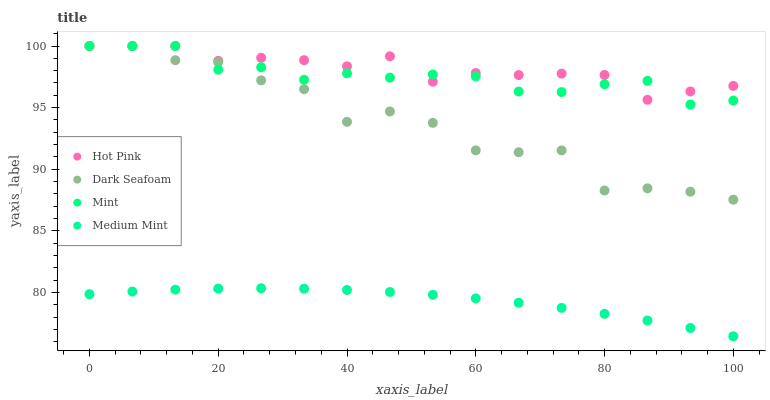Does Medium Mint have the minimum area under the curve?
Answer yes or no. Yes. Does Hot Pink have the maximum area under the curve?
Answer yes or no. Yes. Does Dark Seafoam have the minimum area under the curve?
Answer yes or no. No. Does Dark Seafoam have the maximum area under the curve?
Answer yes or no. No. Is Medium Mint the smoothest?
Answer yes or no. Yes. Is Dark Seafoam the roughest?
Answer yes or no. Yes. Is Hot Pink the smoothest?
Answer yes or no. No. Is Hot Pink the roughest?
Answer yes or no. No. Does Medium Mint have the lowest value?
Answer yes or no. Yes. Does Dark Seafoam have the lowest value?
Answer yes or no. No. Does Mint have the highest value?
Answer yes or no. Yes. Is Medium Mint less than Mint?
Answer yes or no. Yes. Is Dark Seafoam greater than Medium Mint?
Answer yes or no. Yes. Does Hot Pink intersect Mint?
Answer yes or no. Yes. Is Hot Pink less than Mint?
Answer yes or no. No. Is Hot Pink greater than Mint?
Answer yes or no. No. Does Medium Mint intersect Mint?
Answer yes or no. No. 